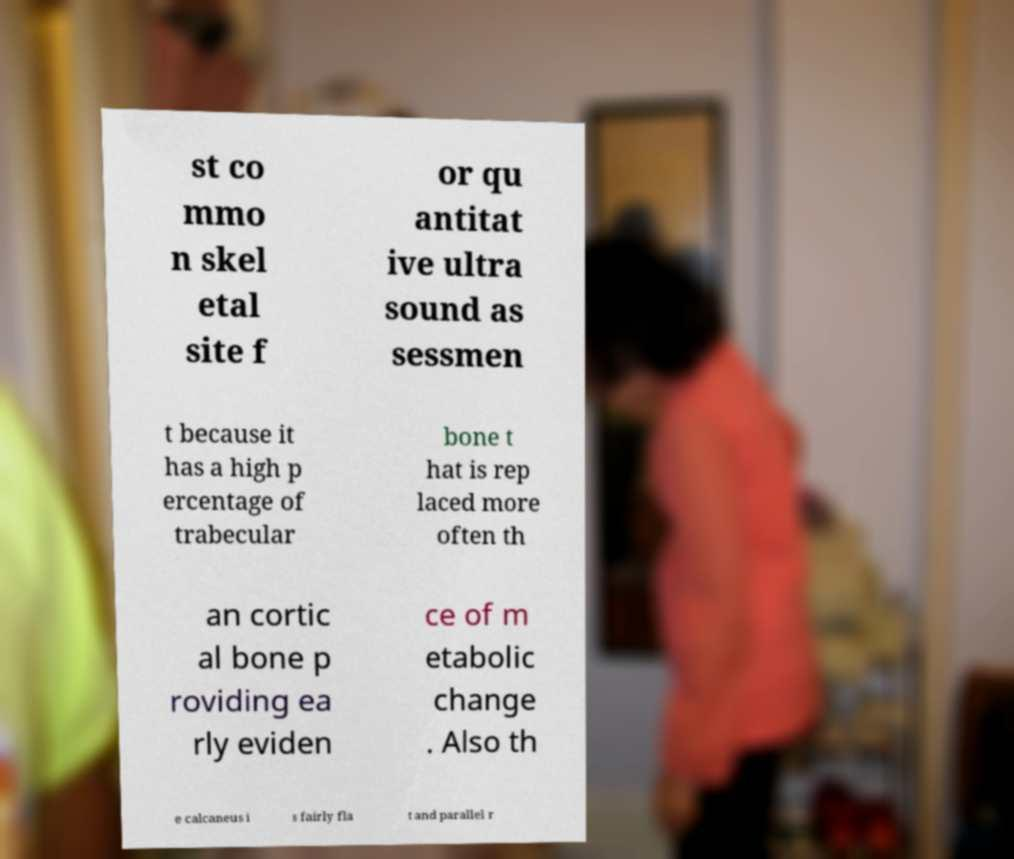Please read and relay the text visible in this image. What does it say? st co mmo n skel etal site f or qu antitat ive ultra sound as sessmen t because it has a high p ercentage of trabecular bone t hat is rep laced more often th an cortic al bone p roviding ea rly eviden ce of m etabolic change . Also th e calcaneus i s fairly fla t and parallel r 